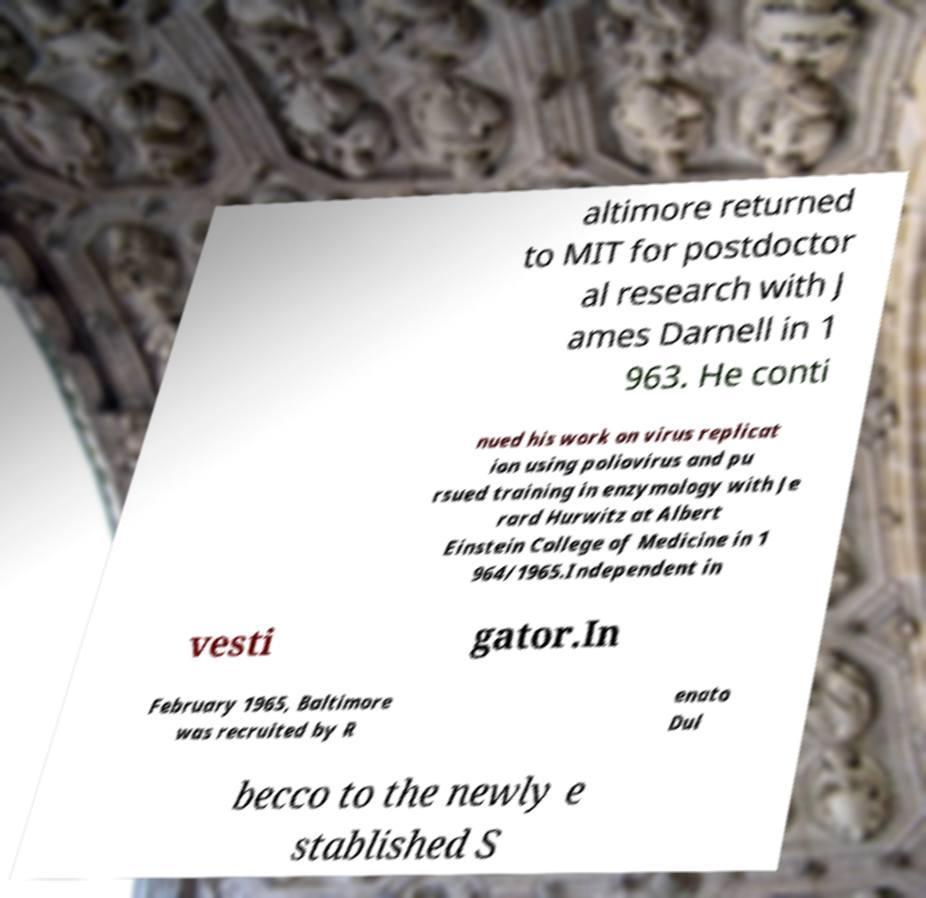Could you extract and type out the text from this image? altimore returned to MIT for postdoctor al research with J ames Darnell in 1 963. He conti nued his work on virus replicat ion using poliovirus and pu rsued training in enzymology with Je rard Hurwitz at Albert Einstein College of Medicine in 1 964/1965.Independent in vesti gator.In February 1965, Baltimore was recruited by R enato Dul becco to the newly e stablished S 